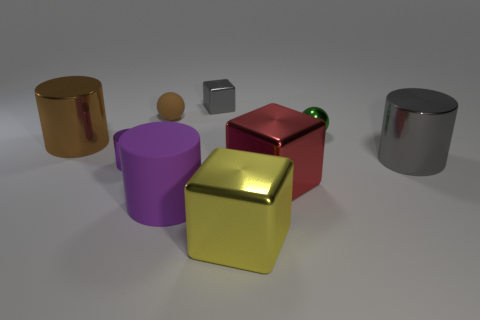Can you describe the arrangement of the objects in the image in terms of their colors and proximity to each other? Certainly! There are six objects in the image, each boasting a unique hue. Starting from the left, a large golden cylinder stands adjacent to a smaller purple cylinder and a tiny wooden sphere. In the center lies a prominent red cube with a green sphere on top, and to the right, a small metallic cube and a large silver cylinder complete the assemblage. They are arranged in an arc, showcasing a vibrant spectrum and giving us a sense of depth and dimension. 